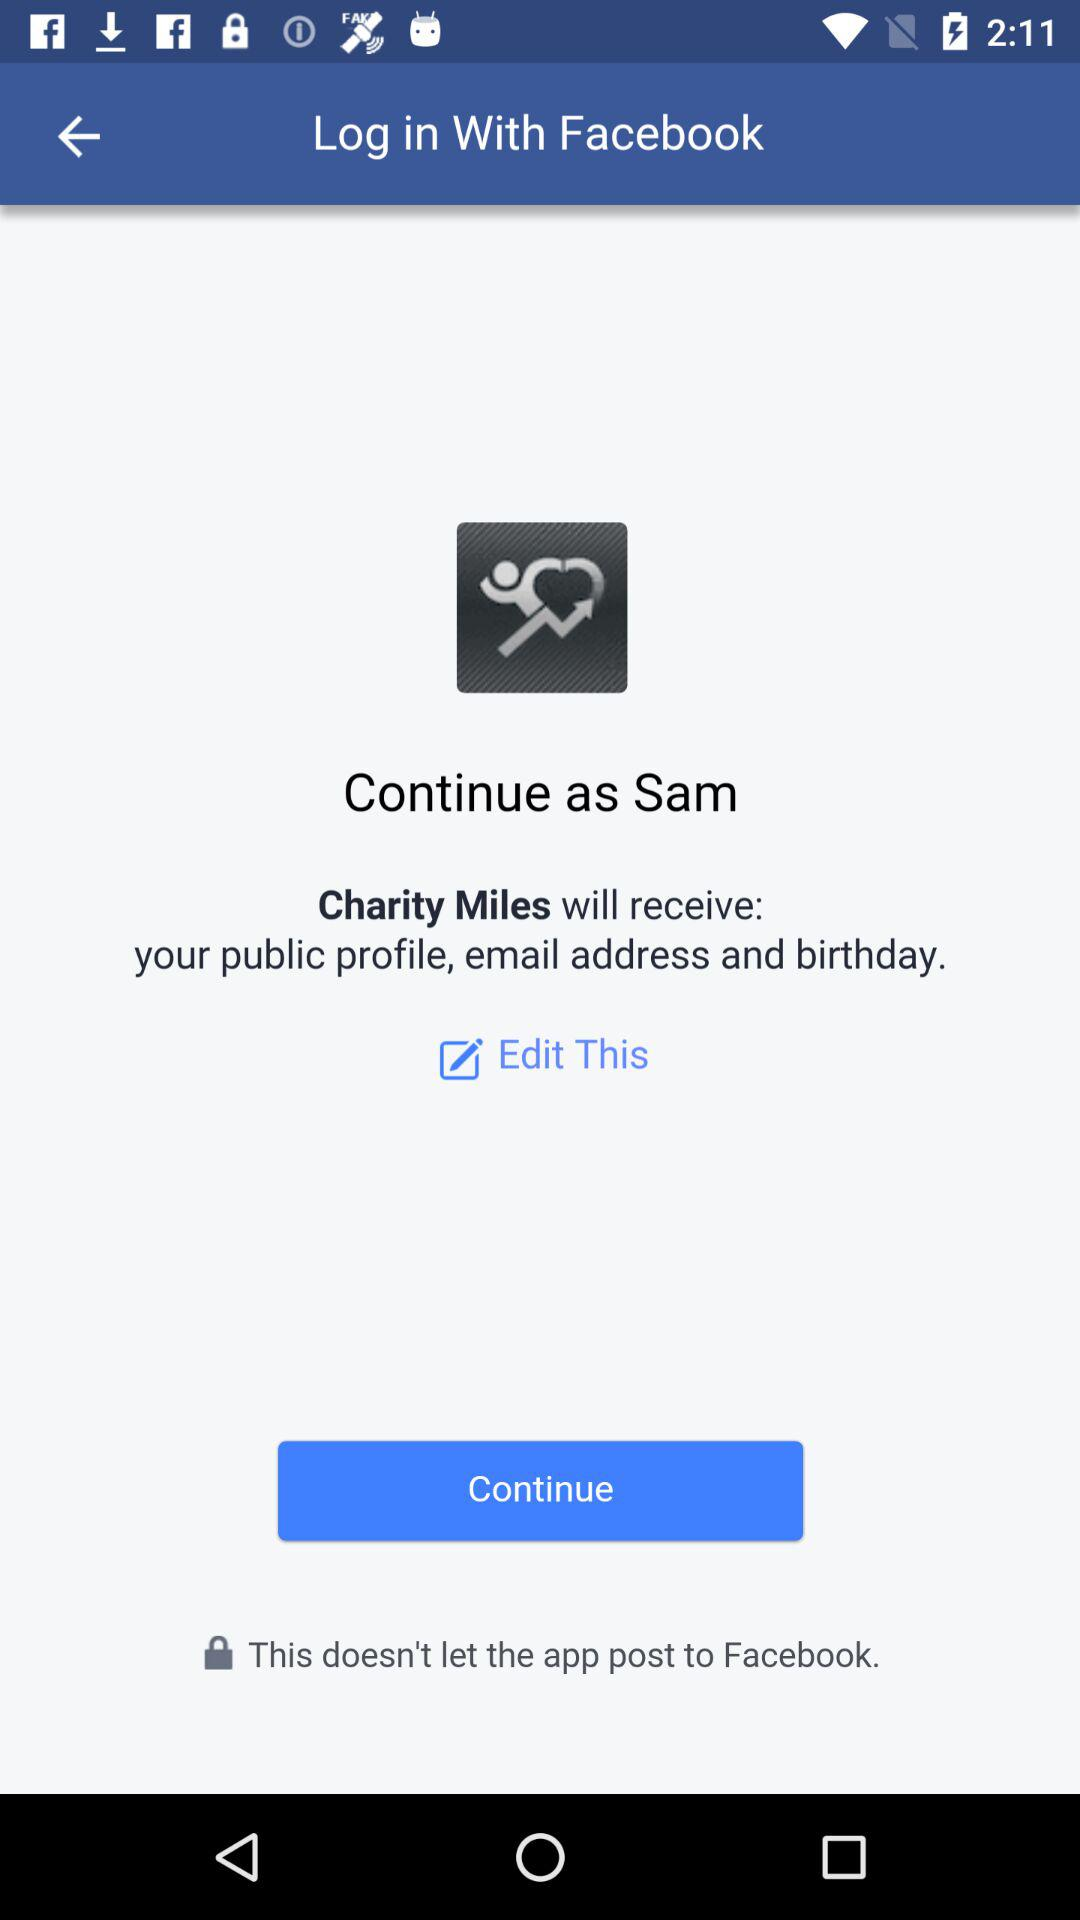Which option is selected?
When the provided information is insufficient, respond with <no answer>. <no answer> 